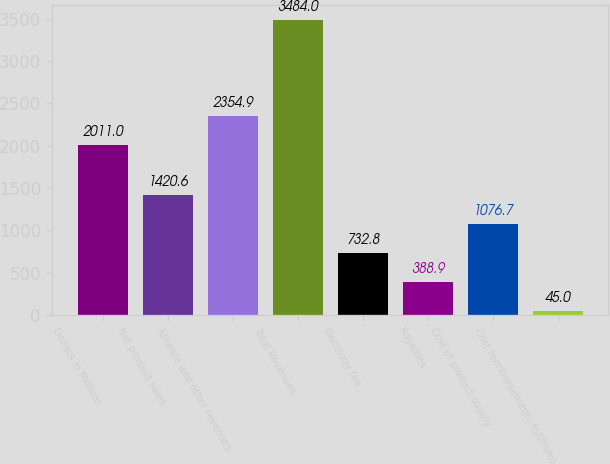<chart> <loc_0><loc_0><loc_500><loc_500><bar_chart><fcel>Dollars in Millions<fcel>Net product sales<fcel>Alliance and other revenues<fcel>Total Revenues<fcel>Oncology fee<fcel>Royalties<fcel>Cost of product supply<fcel>Cost reimbursements to/(from)<nl><fcel>2011<fcel>1420.6<fcel>2354.9<fcel>3484<fcel>732.8<fcel>388.9<fcel>1076.7<fcel>45<nl></chart> 